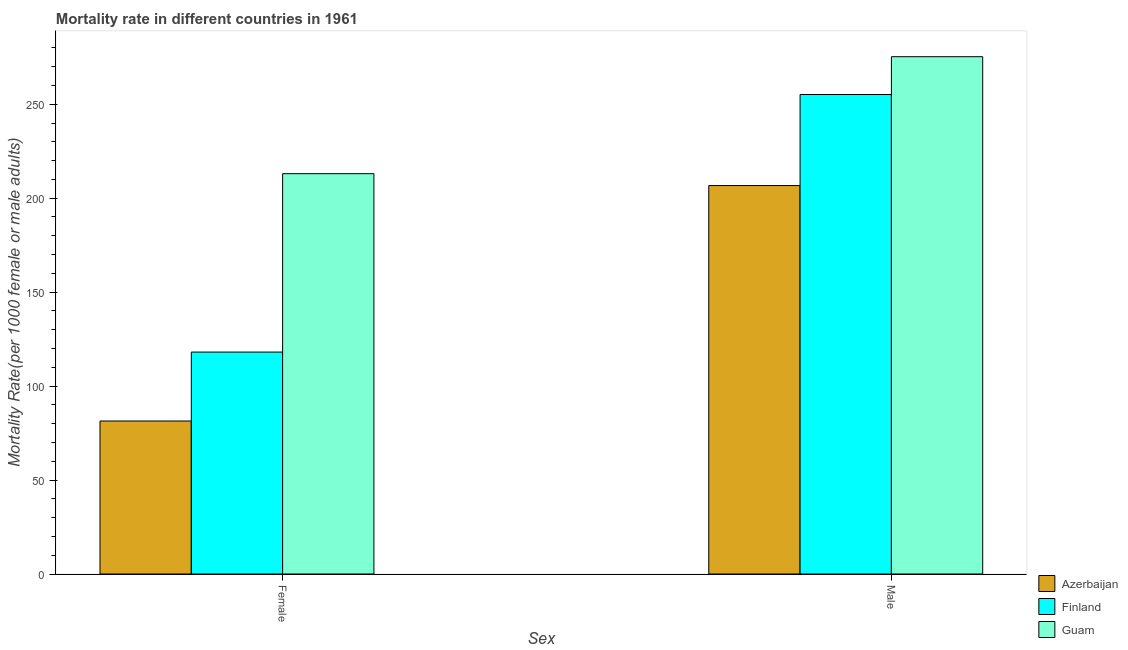How many groups of bars are there?
Provide a succinct answer. 2. How many bars are there on the 2nd tick from the left?
Your response must be concise. 3. How many bars are there on the 1st tick from the right?
Ensure brevity in your answer.  3. What is the male mortality rate in Finland?
Your response must be concise. 255.17. Across all countries, what is the maximum male mortality rate?
Ensure brevity in your answer.  275.3. Across all countries, what is the minimum female mortality rate?
Provide a short and direct response. 81.43. In which country was the female mortality rate maximum?
Provide a short and direct response. Guam. In which country was the female mortality rate minimum?
Provide a short and direct response. Azerbaijan. What is the total female mortality rate in the graph?
Your response must be concise. 412.59. What is the difference between the female mortality rate in Azerbaijan and that in Finland?
Offer a very short reply. -36.68. What is the difference between the female mortality rate in Guam and the male mortality rate in Azerbaijan?
Your response must be concise. 6.32. What is the average female mortality rate per country?
Make the answer very short. 137.53. What is the difference between the male mortality rate and female mortality rate in Azerbaijan?
Offer a very short reply. 125.29. In how many countries, is the male mortality rate greater than 60 ?
Ensure brevity in your answer.  3. What is the ratio of the male mortality rate in Guam to that in Finland?
Your answer should be compact. 1.08. What does the 2nd bar from the left in Male represents?
Your response must be concise. Finland. What does the 2nd bar from the right in Male represents?
Make the answer very short. Finland. Are all the bars in the graph horizontal?
Offer a terse response. No. What is the difference between two consecutive major ticks on the Y-axis?
Give a very brief answer. 50. Are the values on the major ticks of Y-axis written in scientific E-notation?
Provide a succinct answer. No. What is the title of the graph?
Provide a short and direct response. Mortality rate in different countries in 1961. What is the label or title of the X-axis?
Offer a terse response. Sex. What is the label or title of the Y-axis?
Ensure brevity in your answer.  Mortality Rate(per 1000 female or male adults). What is the Mortality Rate(per 1000 female or male adults) of Azerbaijan in Female?
Ensure brevity in your answer.  81.43. What is the Mortality Rate(per 1000 female or male adults) of Finland in Female?
Provide a short and direct response. 118.11. What is the Mortality Rate(per 1000 female or male adults) in Guam in Female?
Your answer should be compact. 213.04. What is the Mortality Rate(per 1000 female or male adults) of Azerbaijan in Male?
Offer a very short reply. 206.73. What is the Mortality Rate(per 1000 female or male adults) of Finland in Male?
Offer a terse response. 255.17. What is the Mortality Rate(per 1000 female or male adults) of Guam in Male?
Your answer should be very brief. 275.3. Across all Sex, what is the maximum Mortality Rate(per 1000 female or male adults) in Azerbaijan?
Make the answer very short. 206.73. Across all Sex, what is the maximum Mortality Rate(per 1000 female or male adults) of Finland?
Offer a very short reply. 255.17. Across all Sex, what is the maximum Mortality Rate(per 1000 female or male adults) in Guam?
Give a very brief answer. 275.3. Across all Sex, what is the minimum Mortality Rate(per 1000 female or male adults) in Azerbaijan?
Give a very brief answer. 81.43. Across all Sex, what is the minimum Mortality Rate(per 1000 female or male adults) of Finland?
Your response must be concise. 118.11. Across all Sex, what is the minimum Mortality Rate(per 1000 female or male adults) in Guam?
Your response must be concise. 213.04. What is the total Mortality Rate(per 1000 female or male adults) of Azerbaijan in the graph?
Provide a short and direct response. 288.16. What is the total Mortality Rate(per 1000 female or male adults) in Finland in the graph?
Make the answer very short. 373.28. What is the total Mortality Rate(per 1000 female or male adults) in Guam in the graph?
Your response must be concise. 488.35. What is the difference between the Mortality Rate(per 1000 female or male adults) of Azerbaijan in Female and that in Male?
Offer a terse response. -125.29. What is the difference between the Mortality Rate(per 1000 female or male adults) of Finland in Female and that in Male?
Your answer should be compact. -137.06. What is the difference between the Mortality Rate(per 1000 female or male adults) in Guam in Female and that in Male?
Give a very brief answer. -62.26. What is the difference between the Mortality Rate(per 1000 female or male adults) in Azerbaijan in Female and the Mortality Rate(per 1000 female or male adults) in Finland in Male?
Offer a terse response. -173.73. What is the difference between the Mortality Rate(per 1000 female or male adults) of Azerbaijan in Female and the Mortality Rate(per 1000 female or male adults) of Guam in Male?
Your answer should be very brief. -193.87. What is the difference between the Mortality Rate(per 1000 female or male adults) of Finland in Female and the Mortality Rate(per 1000 female or male adults) of Guam in Male?
Your response must be concise. -157.19. What is the average Mortality Rate(per 1000 female or male adults) of Azerbaijan per Sex?
Make the answer very short. 144.08. What is the average Mortality Rate(per 1000 female or male adults) in Finland per Sex?
Offer a terse response. 186.64. What is the average Mortality Rate(per 1000 female or male adults) in Guam per Sex?
Make the answer very short. 244.17. What is the difference between the Mortality Rate(per 1000 female or male adults) in Azerbaijan and Mortality Rate(per 1000 female or male adults) in Finland in Female?
Ensure brevity in your answer.  -36.68. What is the difference between the Mortality Rate(per 1000 female or male adults) in Azerbaijan and Mortality Rate(per 1000 female or male adults) in Guam in Female?
Your response must be concise. -131.61. What is the difference between the Mortality Rate(per 1000 female or male adults) in Finland and Mortality Rate(per 1000 female or male adults) in Guam in Female?
Give a very brief answer. -94.93. What is the difference between the Mortality Rate(per 1000 female or male adults) in Azerbaijan and Mortality Rate(per 1000 female or male adults) in Finland in Male?
Your answer should be very brief. -48.44. What is the difference between the Mortality Rate(per 1000 female or male adults) of Azerbaijan and Mortality Rate(per 1000 female or male adults) of Guam in Male?
Ensure brevity in your answer.  -68.58. What is the difference between the Mortality Rate(per 1000 female or male adults) of Finland and Mortality Rate(per 1000 female or male adults) of Guam in Male?
Offer a very short reply. -20.14. What is the ratio of the Mortality Rate(per 1000 female or male adults) of Azerbaijan in Female to that in Male?
Provide a short and direct response. 0.39. What is the ratio of the Mortality Rate(per 1000 female or male adults) in Finland in Female to that in Male?
Offer a terse response. 0.46. What is the ratio of the Mortality Rate(per 1000 female or male adults) in Guam in Female to that in Male?
Give a very brief answer. 0.77. What is the difference between the highest and the second highest Mortality Rate(per 1000 female or male adults) of Azerbaijan?
Offer a very short reply. 125.29. What is the difference between the highest and the second highest Mortality Rate(per 1000 female or male adults) in Finland?
Give a very brief answer. 137.06. What is the difference between the highest and the second highest Mortality Rate(per 1000 female or male adults) of Guam?
Make the answer very short. 62.26. What is the difference between the highest and the lowest Mortality Rate(per 1000 female or male adults) in Azerbaijan?
Your answer should be compact. 125.29. What is the difference between the highest and the lowest Mortality Rate(per 1000 female or male adults) in Finland?
Provide a succinct answer. 137.06. What is the difference between the highest and the lowest Mortality Rate(per 1000 female or male adults) in Guam?
Your answer should be very brief. 62.26. 